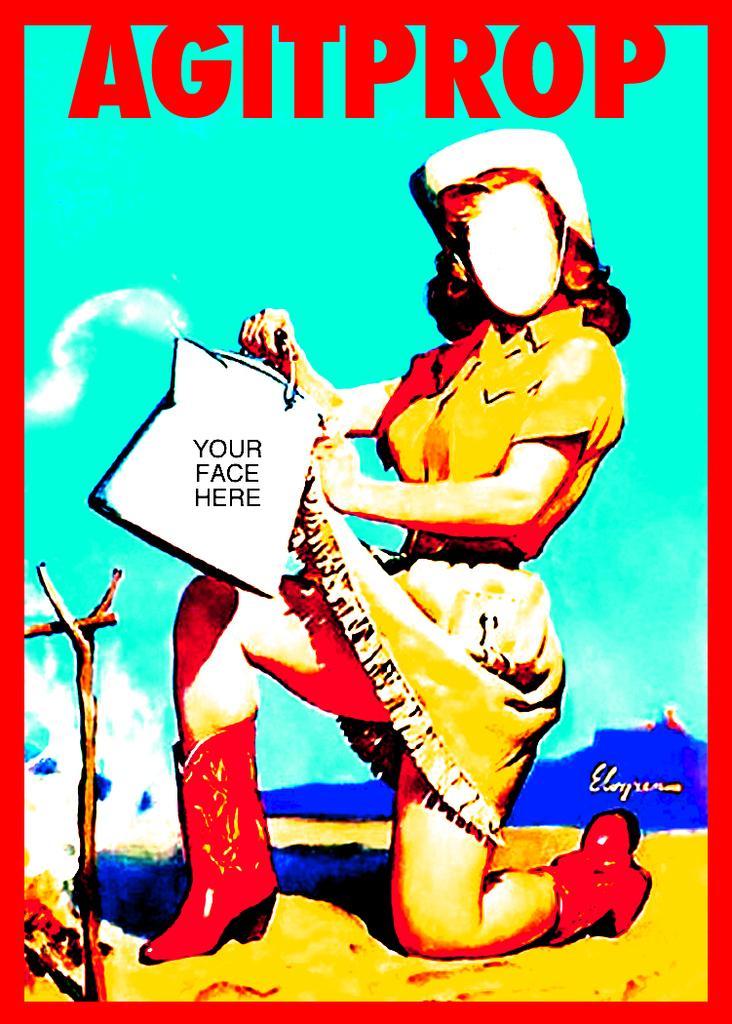Could you give a brief overview of what you see in this image? In the image in the center,we can see one poster. On the poster,we can see one person holding some object and we can see something written on it. On the object,it is written as "Your Face Here". 